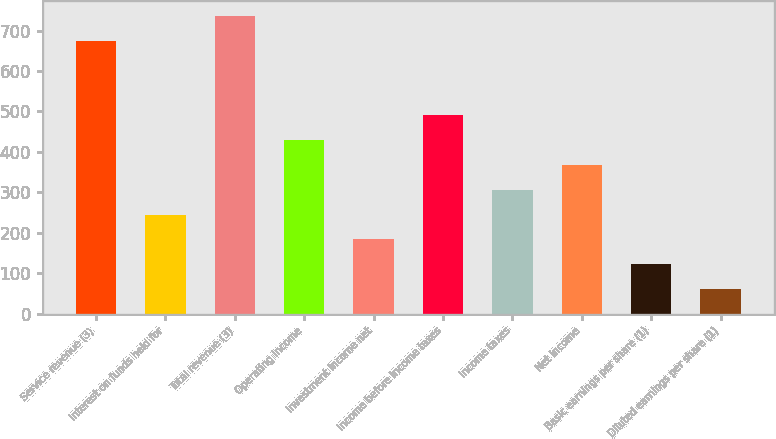<chart> <loc_0><loc_0><loc_500><loc_500><bar_chart><fcel>Service revenue (3)<fcel>Interest on funds held for<fcel>Total revenue (3)<fcel>Operating income<fcel>Investment income net<fcel>Income before income taxes<fcel>Income taxes<fcel>Net income<fcel>Basic earnings per share (1)<fcel>Diluted earnings per share (1)<nl><fcel>674.39<fcel>245.47<fcel>735.66<fcel>429.29<fcel>184.19<fcel>490.57<fcel>306.75<fcel>368.02<fcel>122.91<fcel>61.63<nl></chart> 